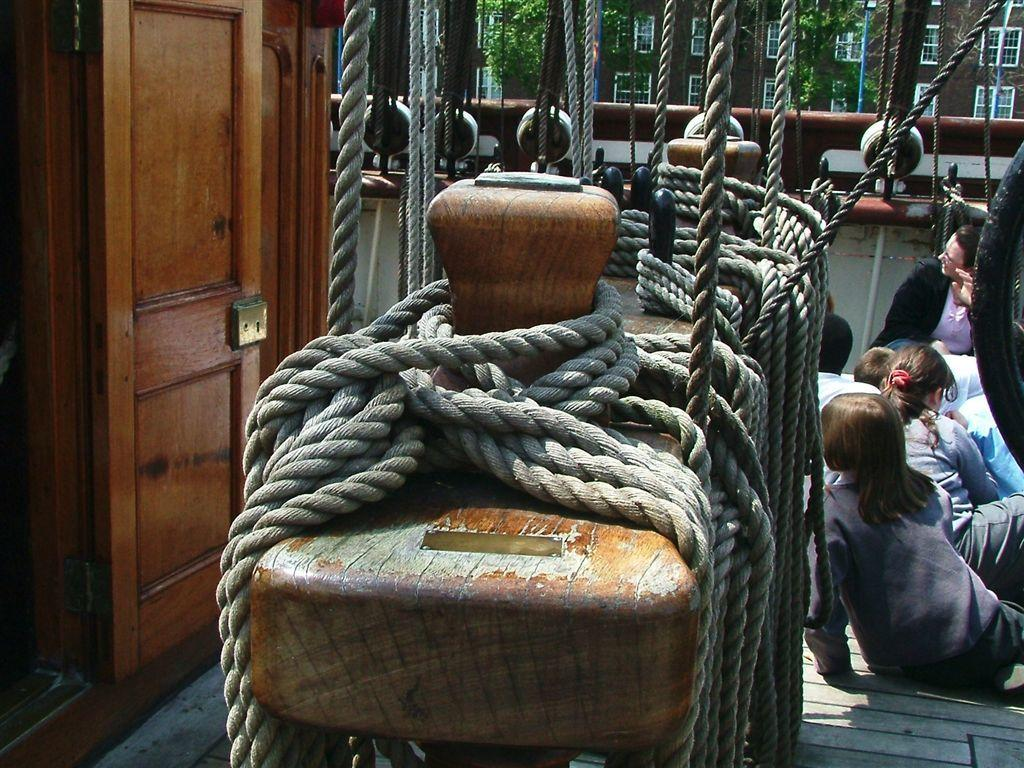What are the people in the image doing? There is a group of people sitting in the image. What objects can be seen in the image besides the people? There are ropes in the image. What architectural feature is visible in the image? There is a door in the image. What can be seen in the background of the image? There are trees and a building with windows in the background of the image. What type of field is visible in the image? There is no field visible in the image; it features a group of people sitting, ropes, a door, trees, and a building with windows in the background. 